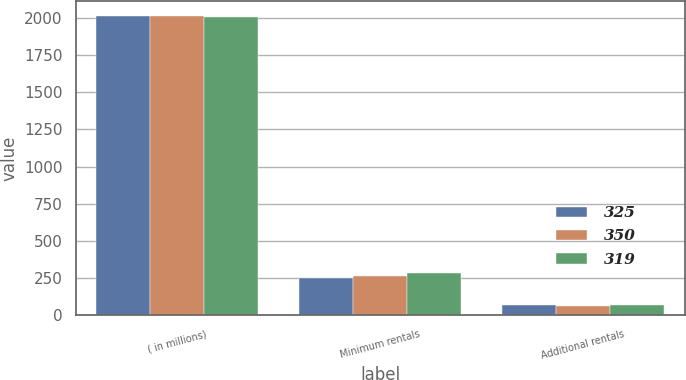Convert chart. <chart><loc_0><loc_0><loc_500><loc_500><stacked_bar_chart><ecel><fcel>( in millions)<fcel>Minimum rentals<fcel>Additional rentals<nl><fcel>325<fcel>2010<fcel>252<fcel>67<nl><fcel>350<fcel>2009<fcel>262<fcel>63<nl><fcel>319<fcel>2008<fcel>283<fcel>67<nl></chart> 